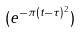<formula> <loc_0><loc_0><loc_500><loc_500>( e ^ { - \pi ( t - \tau ) ^ { 2 } } )</formula> 